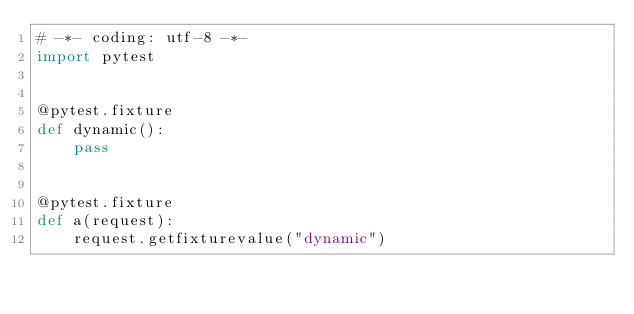Convert code to text. <code><loc_0><loc_0><loc_500><loc_500><_Python_># -*- coding: utf-8 -*-
import pytest


@pytest.fixture
def dynamic():
    pass


@pytest.fixture
def a(request):
    request.getfixturevalue("dynamic")

</code> 